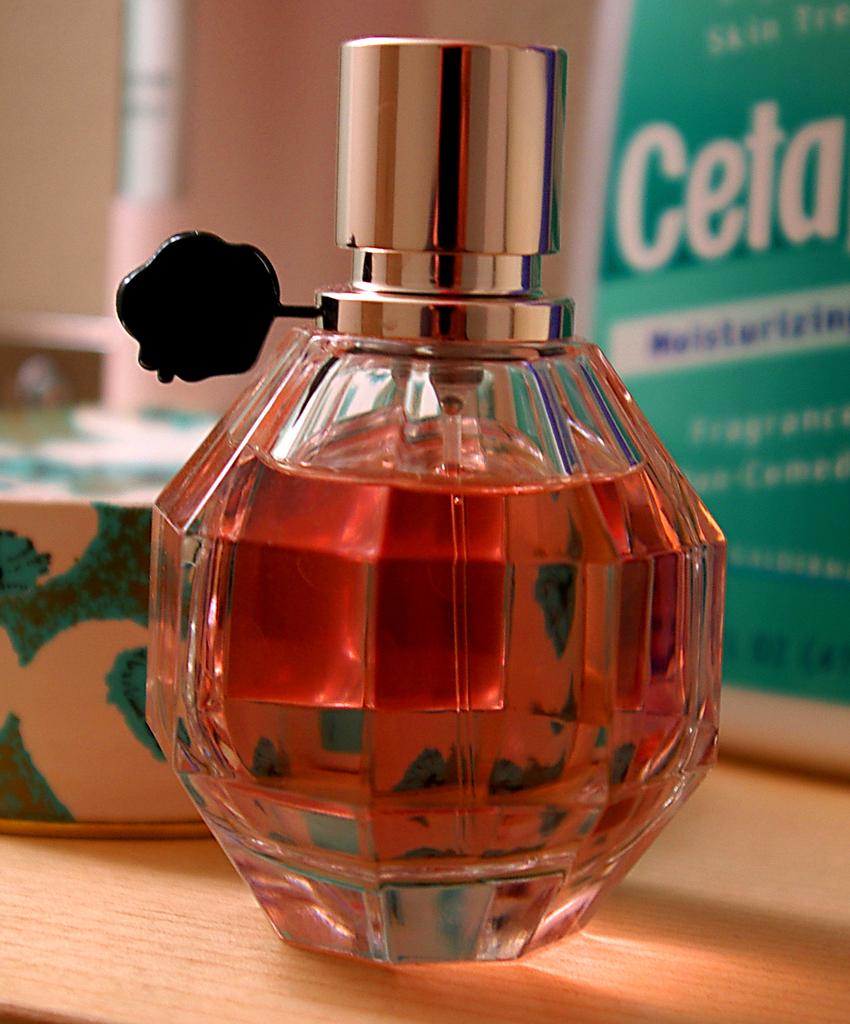What is written on the green and white box in the background?
Offer a very short reply. Ceta. On what surface would you apply the substance on the right?
Ensure brevity in your answer.  Skin. 